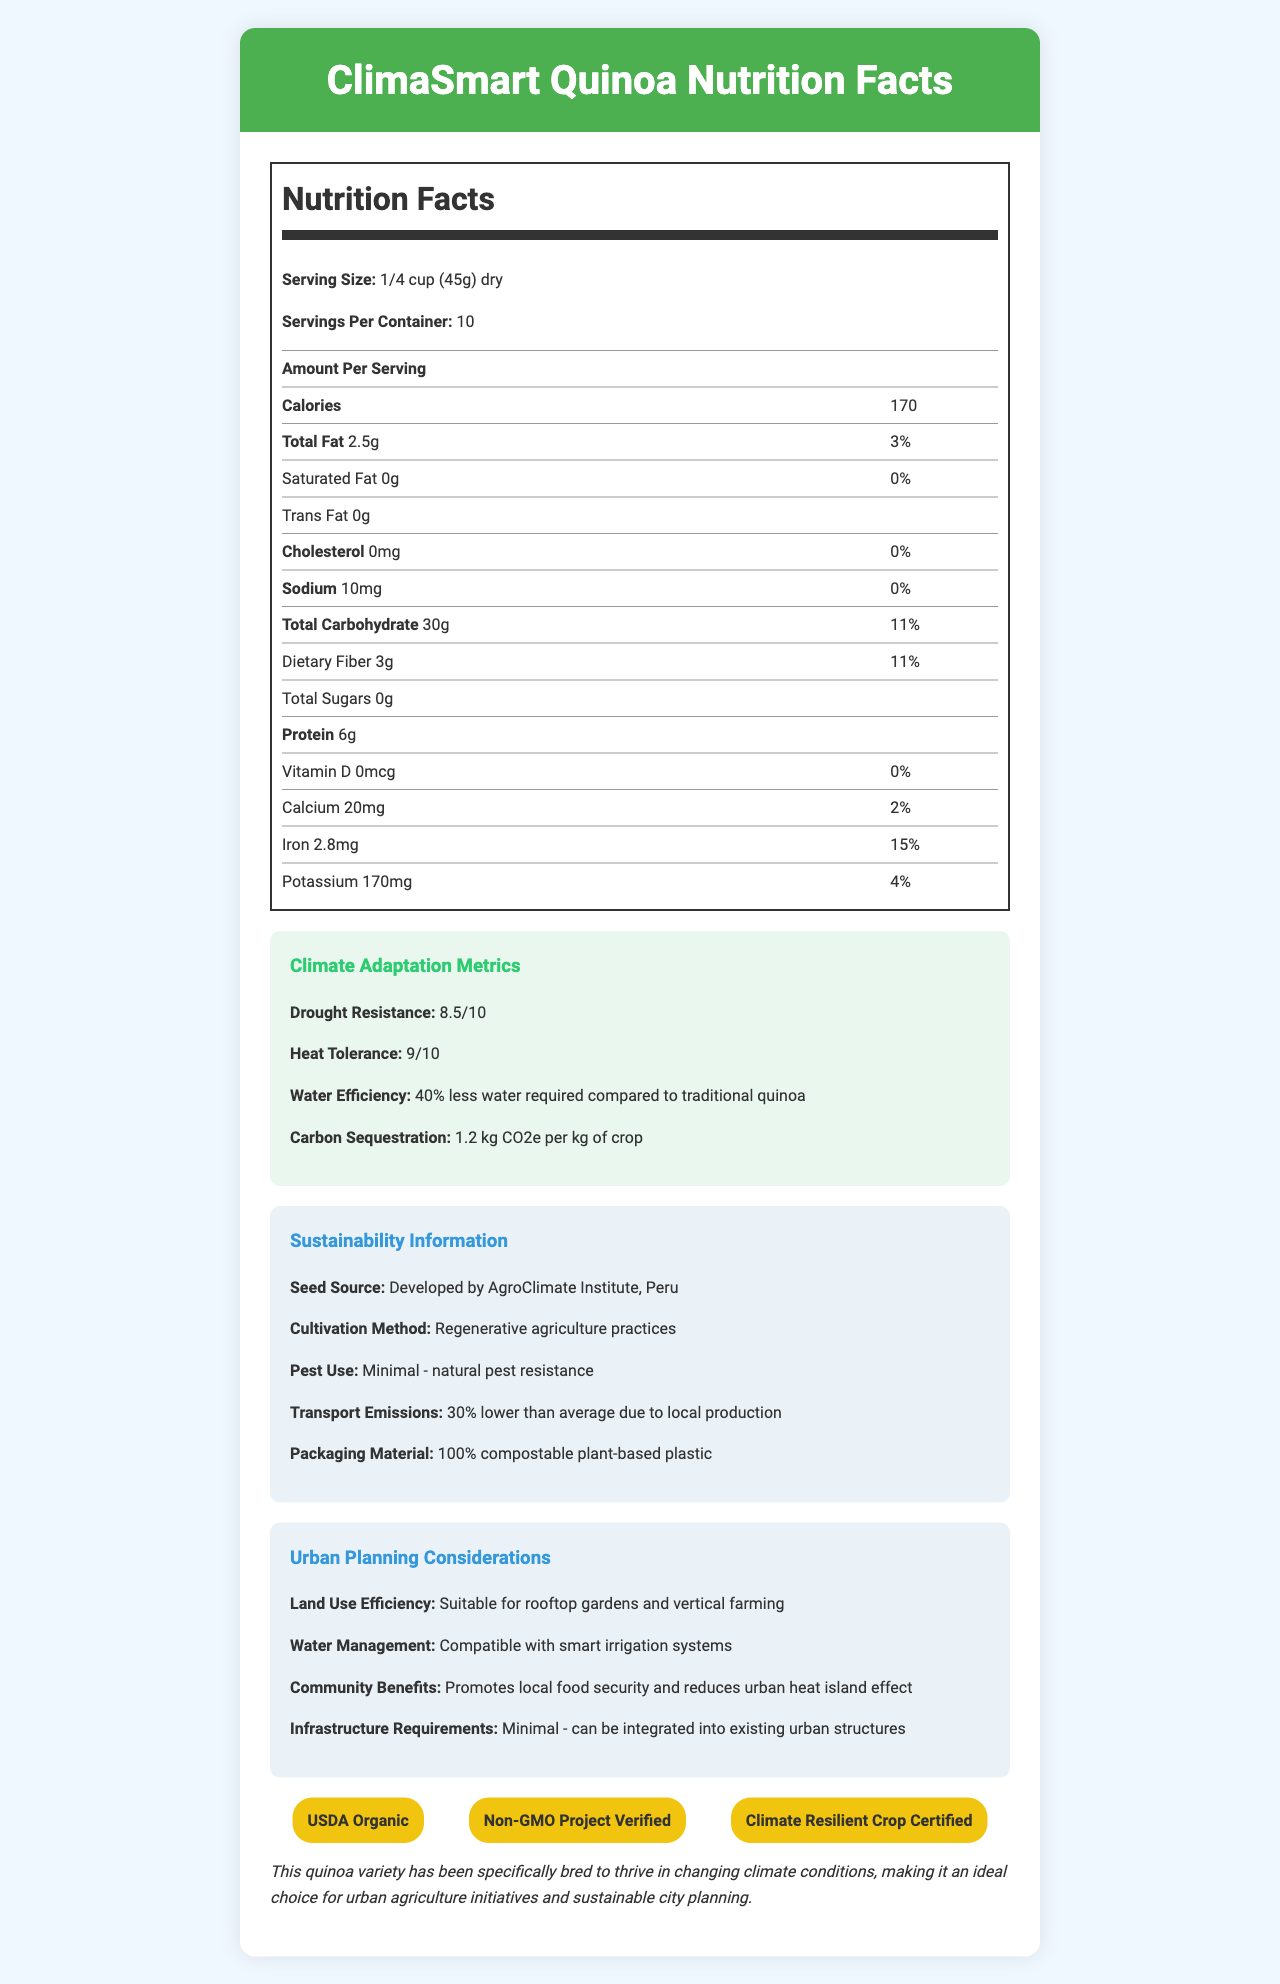what is the serving size for ClimaSmart Quinoa? The serving size is prominently listed as "1/4 cup (45g) dry" at the beginning of the nutrition facts section.
Answer: 1/4 cup (45g) dry how many calories are there per serving? The calories per serving are listed as "170" under the "Amount Per Serving" section of the nutrition label.
Answer: 170 what is the total fat content per serving and its daily value? Under the total fat section, "2.5g" and "3%" are clearly specified.
Answer: 2.5g, 3% how much protein does ClimaSmart Quinoa provide per serving? The protein content is listed as "6g" in the nutrition facts table.
Answer: 6g what is the drought resistance score of ClimaSmart Quinoa? The drought resistance score is given as "8.5/10" in the climate adaptation metrics section.
Answer: 8.5/10 which of the following is not a certification achieved by ClimaSmart Quinoa? A. USDA Organic B. Non-GMO Project Verified C. Fair Trade Certified D. Climate Resilient Crop Certified The document lists certifications as "USDA Organic," "Non-GMO Project Verified," and "Climate Resilient Crop Certified," but not "Fair Trade Certified."
Answer: C how much water does ClimaSmart Quinoa require compared to traditional quinoa? A. 20% less B. 30% less C. 40% less D. 50% less The water efficiency information states "40% less water required compared to traditional quinoa."
Answer: C is ClimaSmart Quinoa suitable for rooftop gardens? The urban planning considerations mention it is "Suitable for rooftop gardens and vertical farming."
Answer: Yes what is the source of the seeds for ClimaSmart Quinoa? The seed source is explicitly listed as "Developed by AgroClimate Institute, Peru."
Answer: Developed by AgroClimate Institute, Peru can you determine the exact protein composition of ClimaSmart Quinoa from the document? The document provides total protein content but does not specify the exact protein composition or amino acid profile.
Answer: Cannot be determined describe the main purpose of the document. The document includes comprehensive sections on nutrition facts, climate adaptation metrics, sustainability information, urban planning benefits, and certifications, aimed at promoting ClimaSmart Quinoa as a sustainable and climate-resilient crop for urban settings.
Answer: To provide nutritional information, climate adaptation metrics, sustainability details, urban planning considerations, and certifications for ClimaSmart Quinoa, a crop variety adapted for changing climate conditions and suitable for urban agriculture. what are some community benefits of growing ClimaSmart Quinoa in urban areas? The community benefits are mentioned in the urban planning considerations section as promoting local food security and reducing urban heat island effect.
Answer: Promotes local food security and reduces urban heat island effect what is the carbon sequestration value for ClimaSmart Quinoa? The climate adaptation metrics indicate a carbon sequestration value of "1.2 kg CO2e per kg of crop."
Answer: 1.2 kg CO2e per kg of crop what cultivation method is used for ClimaSmart Quinoa? The cultivation method is listed as "Regenerative agriculture practices" in the sustainability information section.
Answer: Regenerative agriculture practices what percentage of the daily value for iron does one serving of ClimaSmart Quinoa provide? A. 2% B. 4% C. 11% D. 15% The document lists the daily value for iron as 15% per serving.
Answer: D 